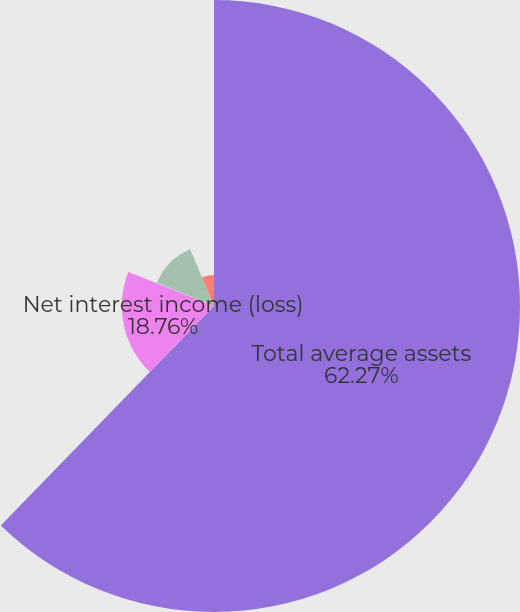<chart> <loc_0><loc_0><loc_500><loc_500><pie_chart><fcel>Total average assets<fcel>Net interest income (loss)<fcel>Noninterest income<fcel>Noninterest expense (2)<fcel>Income (loss) before income<nl><fcel>62.27%<fcel>18.76%<fcel>0.11%<fcel>12.54%<fcel>6.32%<nl></chart> 